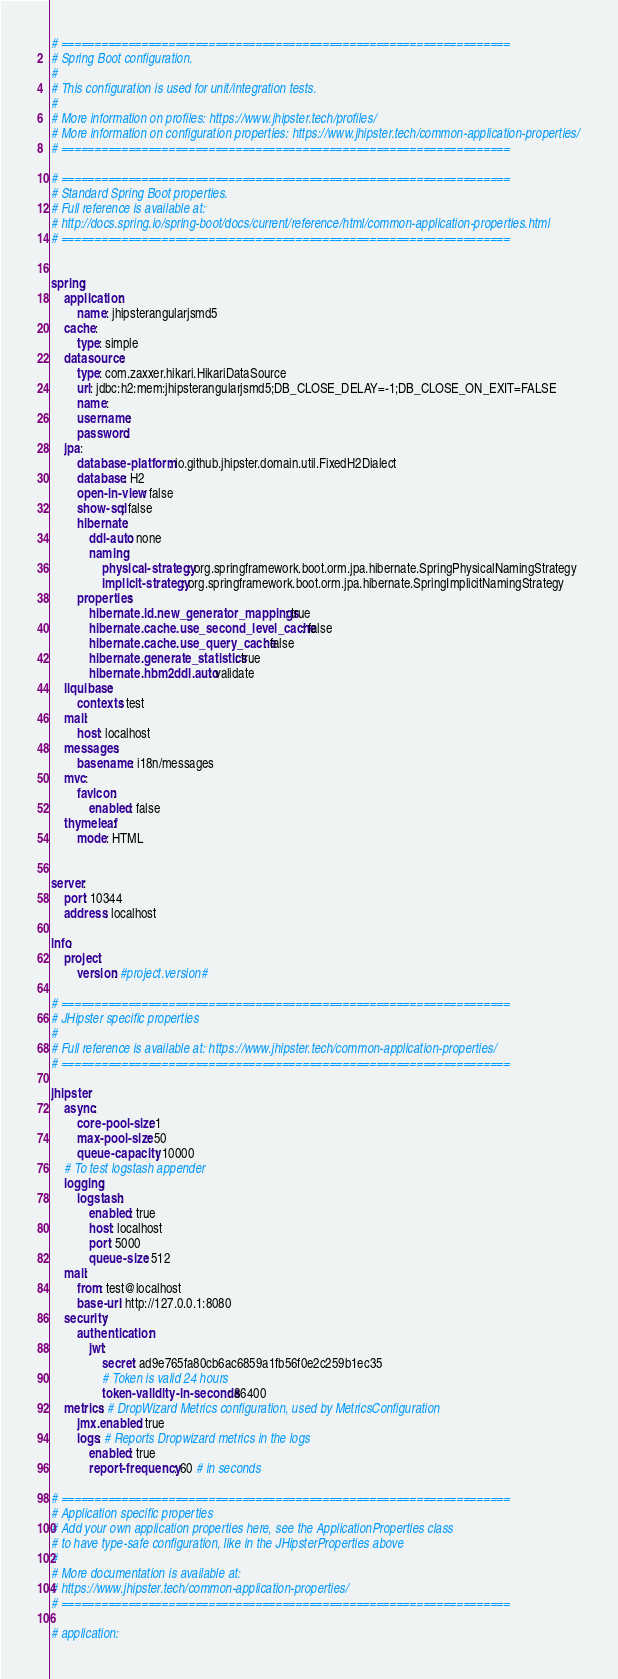Convert code to text. <code><loc_0><loc_0><loc_500><loc_500><_YAML_># ===================================================================
# Spring Boot configuration.
#
# This configuration is used for unit/integration tests.
#
# More information on profiles: https://www.jhipster.tech/profiles/
# More information on configuration properties: https://www.jhipster.tech/common-application-properties/
# ===================================================================

# ===================================================================
# Standard Spring Boot properties.
# Full reference is available at:
# http://docs.spring.io/spring-boot/docs/current/reference/html/common-application-properties.html
# ===================================================================


spring:
    application:
        name: jhipsterangularjsmd5
    cache:
        type: simple
    datasource:
        type: com.zaxxer.hikari.HikariDataSource
        url: jdbc:h2:mem:jhipsterangularjsmd5;DB_CLOSE_DELAY=-1;DB_CLOSE_ON_EXIT=FALSE
        name:
        username:
        password:
    jpa:
        database-platform: io.github.jhipster.domain.util.FixedH2Dialect
        database: H2
        open-in-view: false
        show-sql: false
        hibernate:
            ddl-auto: none
            naming:
                physical-strategy: org.springframework.boot.orm.jpa.hibernate.SpringPhysicalNamingStrategy
                implicit-strategy: org.springframework.boot.orm.jpa.hibernate.SpringImplicitNamingStrategy
        properties:
            hibernate.id.new_generator_mappings: true
            hibernate.cache.use_second_level_cache: false
            hibernate.cache.use_query_cache: false
            hibernate.generate_statistics: true
            hibernate.hbm2ddl.auto: validate
    liquibase:
        contexts: test
    mail:
        host: localhost
    messages:
        basename: i18n/messages
    mvc:
        favicon:
            enabled: false
    thymeleaf:
        mode: HTML
        

server:
    port: 10344
    address: localhost

info:
    project:
        version: #project.version#

# ===================================================================
# JHipster specific properties
#
# Full reference is available at: https://www.jhipster.tech/common-application-properties/
# ===================================================================

jhipster:
    async:
        core-pool-size: 1
        max-pool-size: 50
        queue-capacity: 10000
    # To test logstash appender
    logging:
        logstash:
            enabled: true
            host: localhost
            port: 5000
            queue-size: 512
    mail:
        from: test@localhost
        base-url: http://127.0.0.1:8080
    security:
        authentication:
            jwt:
                secret: ad9e765fa80cb6ac6859a1fb56f0e2c259b1ec35
                # Token is valid 24 hours
                token-validity-in-seconds: 86400
    metrics: # DropWizard Metrics configuration, used by MetricsConfiguration
        jmx.enabled: true
        logs: # Reports Dropwizard metrics in the logs
            enabled: true
            report-frequency: 60 # in seconds

# ===================================================================
# Application specific properties
# Add your own application properties here, see the ApplicationProperties class
# to have type-safe configuration, like in the JHipsterProperties above
#
# More documentation is available at:
# https://www.jhipster.tech/common-application-properties/
# ===================================================================

# application:
</code> 